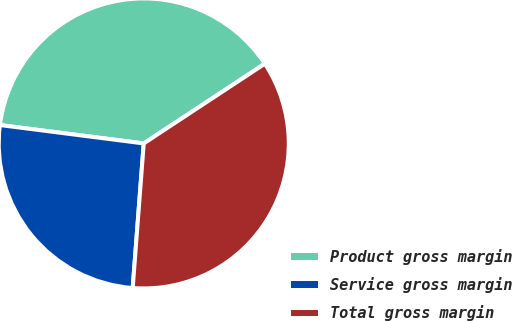<chart> <loc_0><loc_0><loc_500><loc_500><pie_chart><fcel>Product gross margin<fcel>Service gross margin<fcel>Total gross margin<nl><fcel>38.71%<fcel>25.81%<fcel>35.48%<nl></chart> 